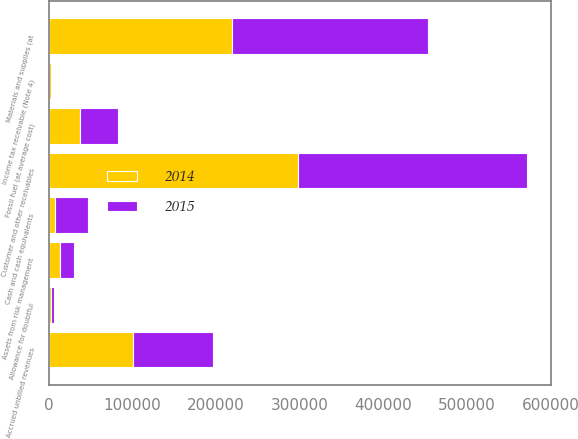Convert chart. <chart><loc_0><loc_0><loc_500><loc_500><stacked_bar_chart><ecel><fcel>Cash and cash equivalents<fcel>Customer and other receivables<fcel>Accrued unbilled revenues<fcel>Allowance for doubtful<fcel>Materials and supplies (at<fcel>Fossil fuel (at average cost)<fcel>Income tax receivable (Note 4)<fcel>Assets from risk management<nl><fcel>2015<fcel>39488<fcel>274691<fcel>96240<fcel>3125<fcel>234234<fcel>45697<fcel>589<fcel>15905<nl><fcel>2014<fcel>7604<fcel>297740<fcel>100533<fcel>3094<fcel>218889<fcel>37097<fcel>3098<fcel>13785<nl></chart> 